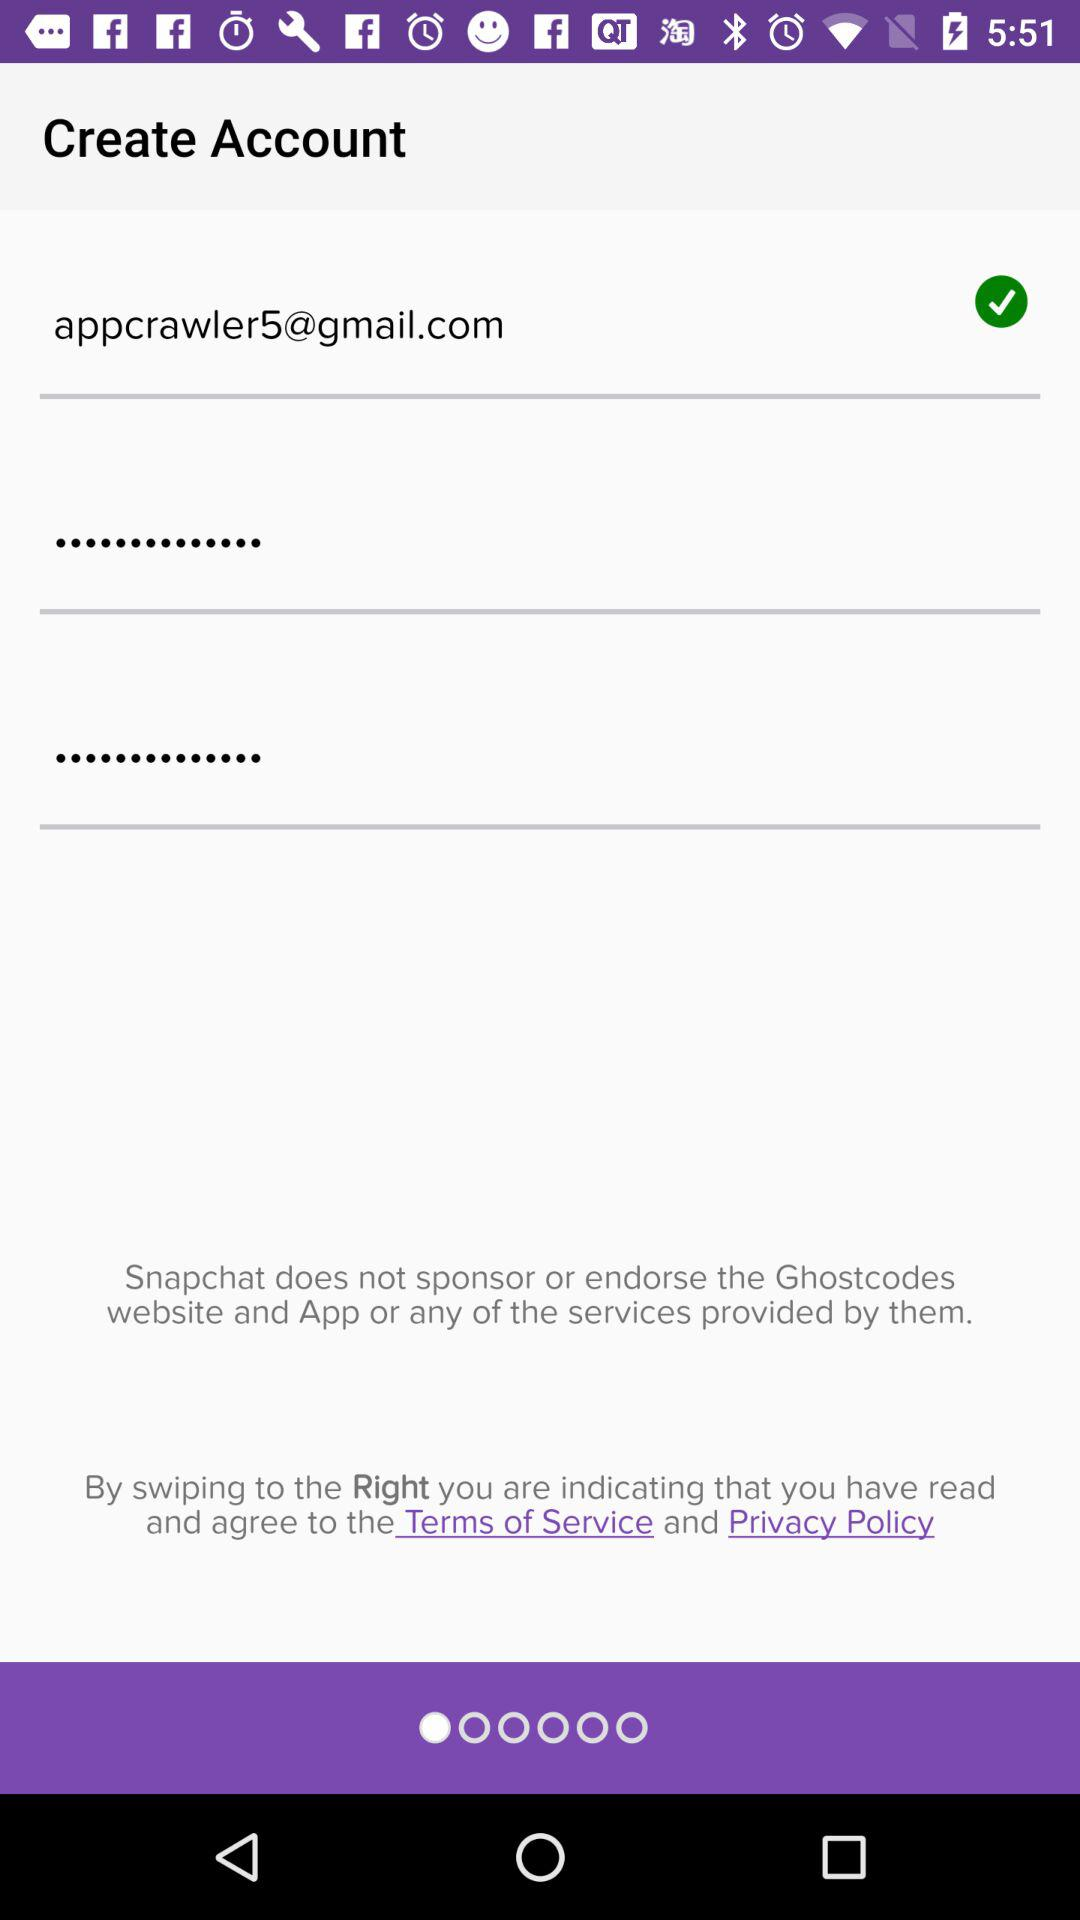What's the Gmail address? The Gmail address is appcrawler5@gmail.com. 